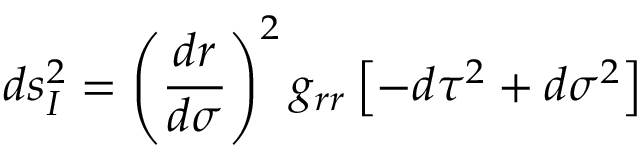<formula> <loc_0><loc_0><loc_500><loc_500>d s _ { I } ^ { 2 } = \left ( \frac { d r } { d \sigma } \right ) ^ { 2 } g _ { r r } \left [ - d \tau ^ { 2 } + d \sigma ^ { 2 } \right ]</formula> 